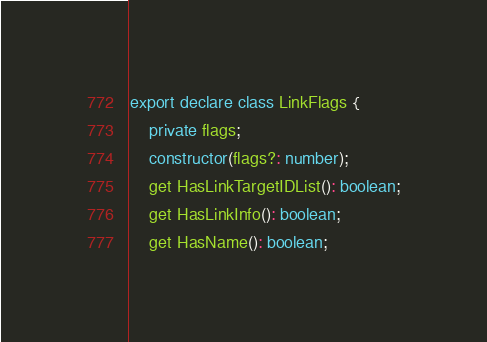Convert code to text. <code><loc_0><loc_0><loc_500><loc_500><_TypeScript_>export declare class LinkFlags {
    private flags;
    constructor(flags?: number);
    get HasLinkTargetIDList(): boolean;
    get HasLinkInfo(): boolean;
    get HasName(): boolean;</code> 